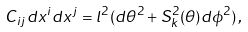<formula> <loc_0><loc_0><loc_500><loc_500>C _ { i j } d x ^ { i } d x ^ { j } = l ^ { 2 } ( d \theta ^ { 2 } + S _ { k } ^ { 2 } ( \theta ) d \phi ^ { 2 } ) \, ,</formula> 